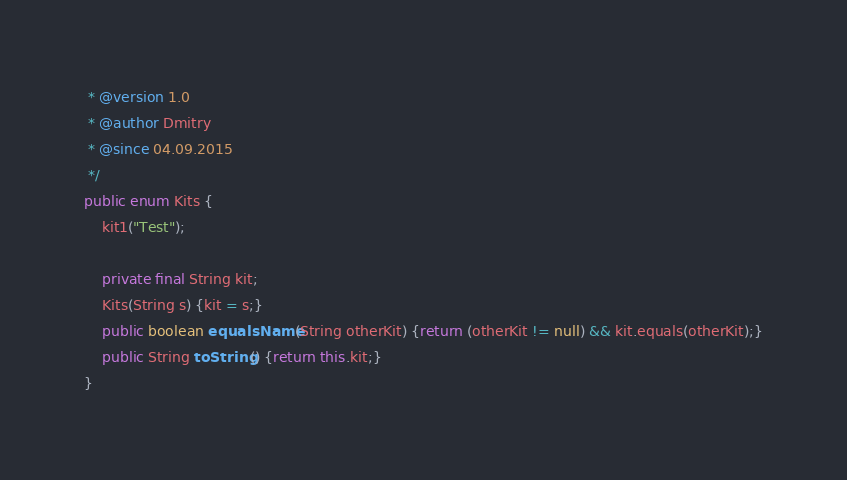<code> <loc_0><loc_0><loc_500><loc_500><_Java_> * @version 1.0
 * @author Dmitry
 * @since 04.09.2015
 */
public enum Kits {
    kit1("Test");

    private final String kit;
    Kits(String s) {kit = s;}
    public boolean equalsName(String otherKit) {return (otherKit != null) && kit.equals(otherKit);}
    public String toString() {return this.kit;}
}
</code> 